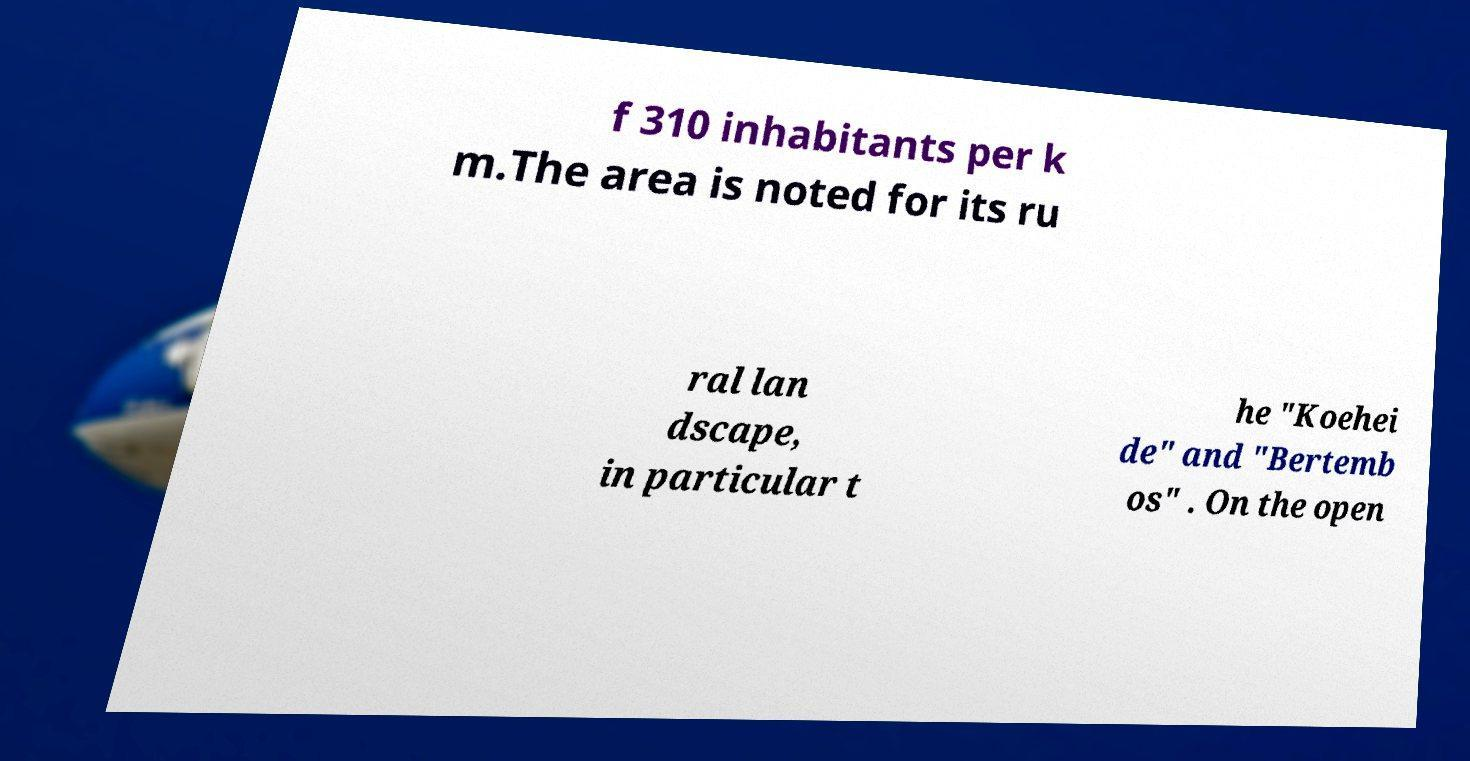Could you extract and type out the text from this image? f 310 inhabitants per k m.The area is noted for its ru ral lan dscape, in particular t he "Koehei de" and "Bertemb os" . On the open 